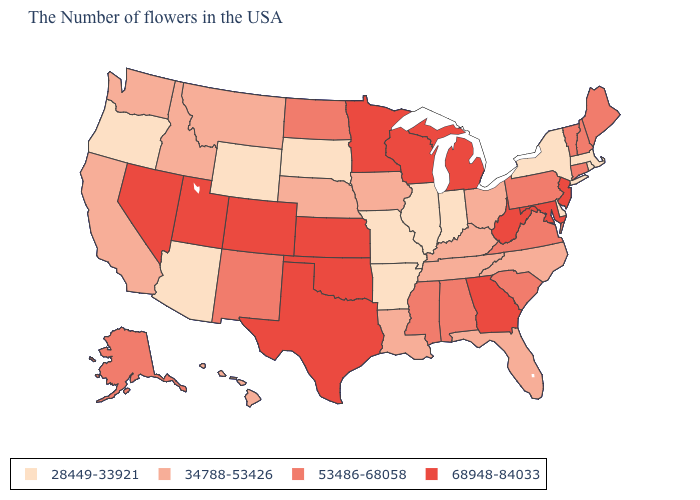Does North Carolina have the lowest value in the USA?
Answer briefly. No. How many symbols are there in the legend?
Concise answer only. 4. What is the value of Virginia?
Quick response, please. 53486-68058. What is the highest value in the West ?
Write a very short answer. 68948-84033. What is the lowest value in states that border North Dakota?
Keep it brief. 28449-33921. Which states have the lowest value in the West?
Write a very short answer. Wyoming, Arizona, Oregon. Does Oklahoma have the highest value in the South?
Answer briefly. Yes. Name the states that have a value in the range 34788-53426?
Be succinct. North Carolina, Ohio, Florida, Kentucky, Tennessee, Louisiana, Iowa, Nebraska, Montana, Idaho, California, Washington, Hawaii. Does Minnesota have a higher value than Utah?
Be succinct. No. Among the states that border Idaho , does Wyoming have the lowest value?
Concise answer only. Yes. Does Alabama have the lowest value in the South?
Short answer required. No. Does New Hampshire have the highest value in the USA?
Answer briefly. No. What is the value of Rhode Island?
Concise answer only. 28449-33921. What is the lowest value in the USA?
Keep it brief. 28449-33921. Name the states that have a value in the range 68948-84033?
Be succinct. New Jersey, Maryland, West Virginia, Georgia, Michigan, Wisconsin, Minnesota, Kansas, Oklahoma, Texas, Colorado, Utah, Nevada. 